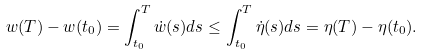Convert formula to latex. <formula><loc_0><loc_0><loc_500><loc_500>w ( T ) - w ( t _ { 0 } ) = \int _ { t _ { 0 } } ^ { T } \dot { w } ( s ) d s \leq \int _ { t _ { 0 } } ^ { T } \dot { \eta } ( s ) d s = \eta ( T ) - \eta ( t _ { 0 } ) .</formula> 